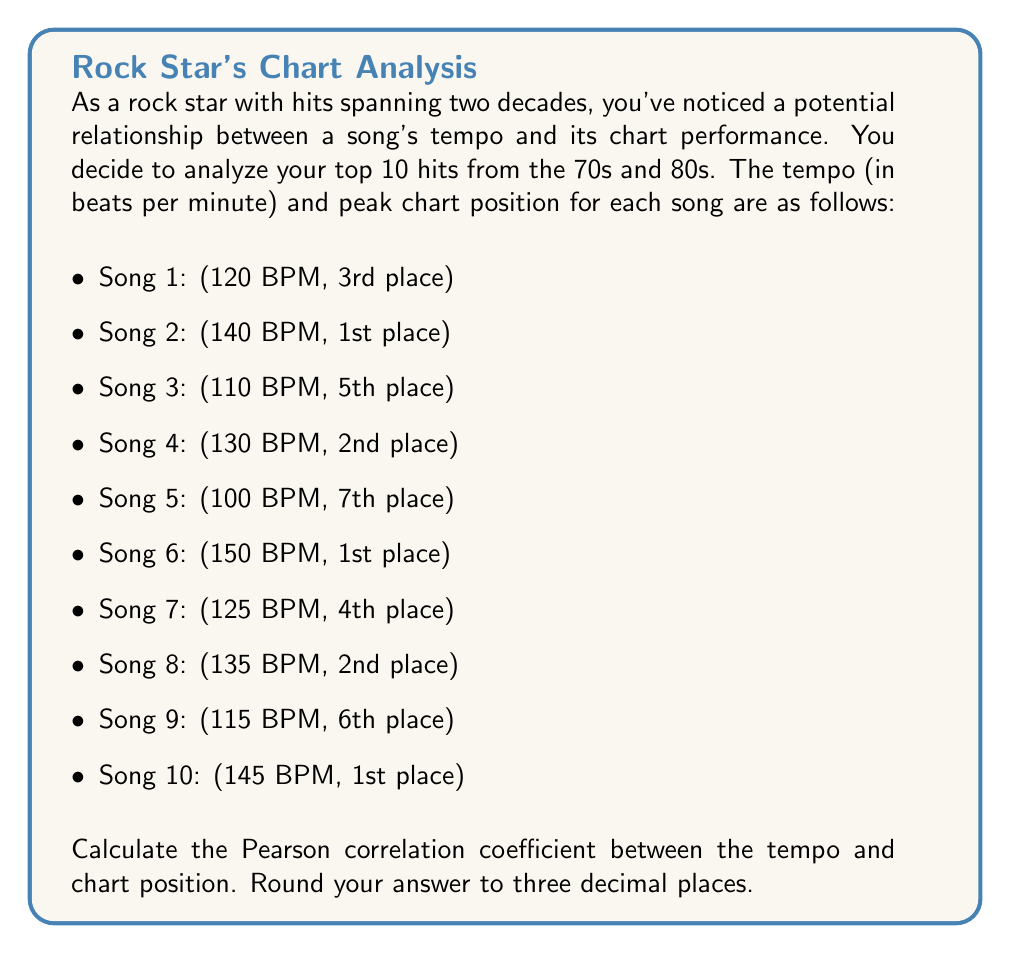Give your solution to this math problem. To calculate the Pearson correlation coefficient between tempo and chart position, we'll follow these steps:

1. Calculate the means of tempo ($\bar{x}$) and chart position ($\bar{y}$).
2. Calculate the deviations from the mean for both variables.
3. Calculate the products of these deviations.
4. Calculate the sum of squared deviations for each variable.
5. Apply the Pearson correlation coefficient formula.

Let's begin:

1. Calculate means:
   $\bar{x} = \frac{120 + 140 + 110 + 130 + 100 + 150 + 125 + 135 + 115 + 145}{10} = 127$ BPM
   $\bar{y} = \frac{3 + 1 + 5 + 2 + 7 + 1 + 4 + 2 + 6 + 1}{10} = 3.2$

2. Calculate deviations:
   
   | Song | x (Tempo) | y (Position) | x - $\bar{x}$ | y - $\bar{y}$ |
   |------|-----------|--------------|---------------|---------------|
   | 1    | 120       | 3            | -7            | -0.2          |
   | 2    | 140       | 1            | 13            | -2.2          |
   | 3    | 110       | 5            | -17           | 1.8           |
   | 4    | 130       | 2            | 3             | -1.2          |
   | 5    | 100       | 7            | -27           | 3.8           |
   | 6    | 150       | 1            | 23            | -2.2          |
   | 7    | 125       | 4            | -2            | 0.8           |
   | 8    | 135       | 2            | 8             | -1.2          |
   | 9    | 115       | 6            | -12           | 2.8           |
   | 10   | 145       | 1            | 18            | -2.2          |

3. Calculate products of deviations:
   
   | Song | (x - $\bar{x}$)(y - $\bar{y}$) |
   |------|--------------------------------|
   | 1    | 1.4                            |
   | 2    | -28.6                          |
   | 3    | -30.6                          |
   | 4    | -3.6                           |
   | 5    | -102.6                         |
   | 6    | -50.6                          |
   | 7    | -1.6                           |
   | 8    | -9.6                           |
   | 9    | -33.6                          |
   | 10   | -39.6                          |

   Sum of products: -299

4. Calculate sum of squared deviations:
   $\sum (x - \bar{x})^2 = 2938$
   $\sum (y - \bar{y})^2 = 50.6$

5. Apply the Pearson correlation coefficient formula:

   $$r = \frac{\sum (x - \bar{x})(y - \bar{y})}{\sqrt{\sum (x - \bar{x})^2 \sum (y - \bar{y})^2}}$$

   $$r = \frac{-299}{\sqrt{2938 \times 50.6}} = \frac{-299}{385.7831} = -0.7751$$

Rounding to three decimal places, we get -0.775.
Answer: -0.775 